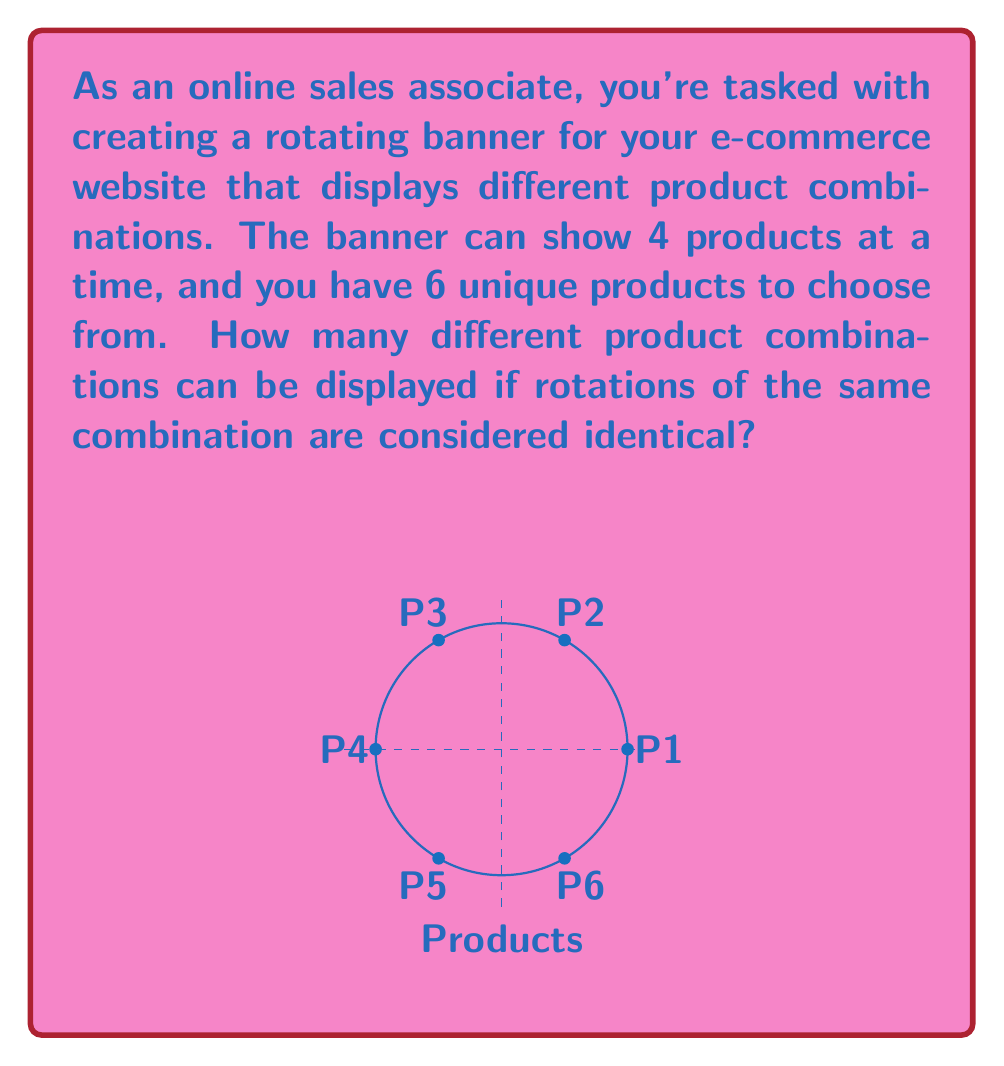Can you answer this question? Let's approach this step-by-step using group theory concepts:

1) We are dealing with combinations of 4 products chosen from 6, where cyclic rotations are considered identical. This is a perfect scenario for using cyclic groups.

2) The total number of ways to choose 4 products from 6 without considering rotations would be $\binom{6}{4} = 15$.

3) However, each combination can be rotated in 4 ways (as there are 4 positions), and these rotations are considered identical in our problem.

4) This means we need to divide our total by 4 to account for these rotations.

5) Mathematically, we're looking at the orbit of each combination under the action of the cyclic group $C_4$ (the group of rotations of order 4).

6) The number of unique combinations is given by the formula:

   $$\text{Number of unique combinations} = \frac{\text{Total combinations}}{\text{Size of each orbit}}$$

7) Substituting our values:

   $$\text{Number of unique combinations} = \frac{\binom{6}{4}}{4} = \frac{15}{4} = 3.75$$

8) Since we can't have a fractional number of combinations, we round up to the nearest whole number.

Therefore, there are 4 unique product combinations that can be displayed on the rotating banner.
Answer: 4 